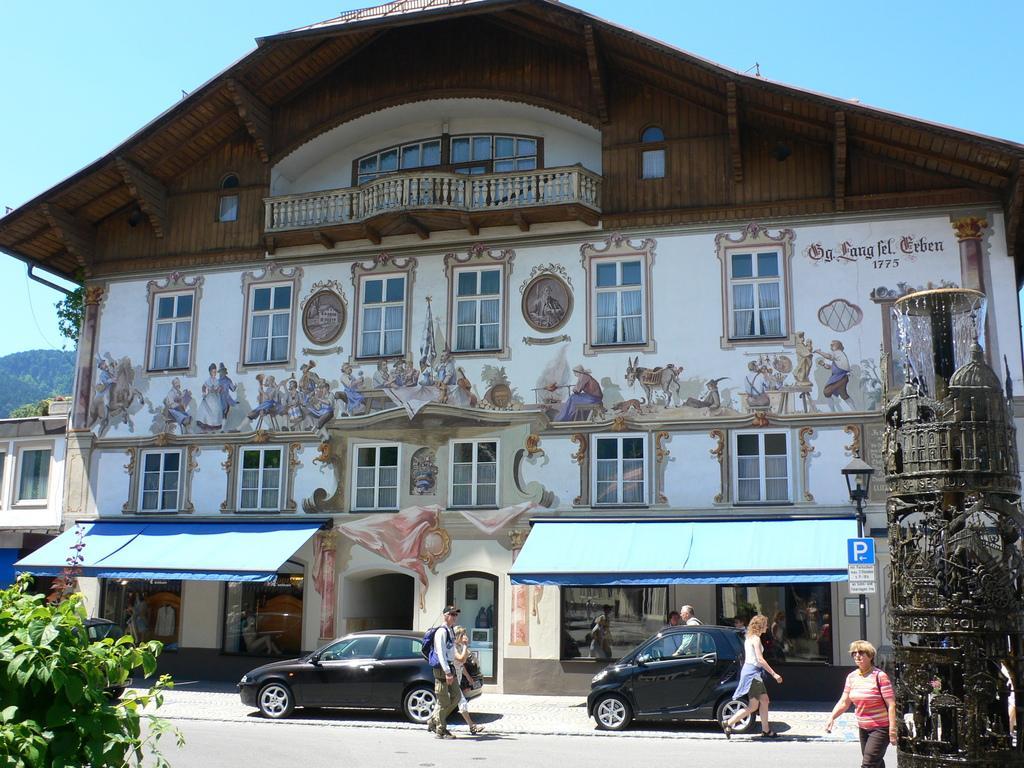Can you describe this image briefly? At the bottom of the image there is a road. Behind the road there are few people walking and also there are two cars. Behind the cars there is a building with walls, roof, glass windows, pillars, balcony and sculptures on it. Below the building there are stores with roofs. At the right corner of the image there is a fountain. At the top of the image in the background there is a sky. 